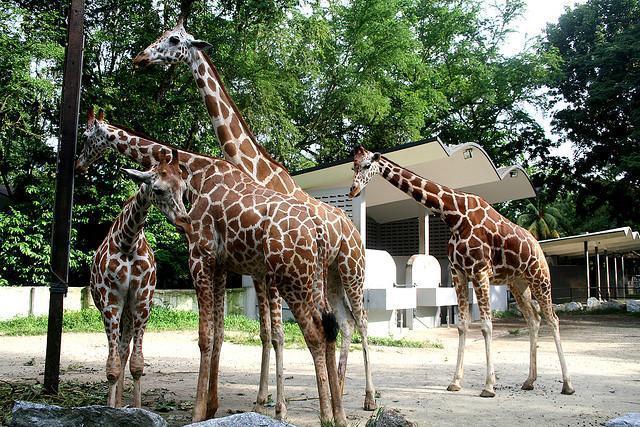How many animals do you see?
Give a very brief answer. 4. How many animals are standing around?
Give a very brief answer. 4. How many giraffes are there?
Give a very brief answer. 4. How many people are holding book in their hand ?
Give a very brief answer. 0. 